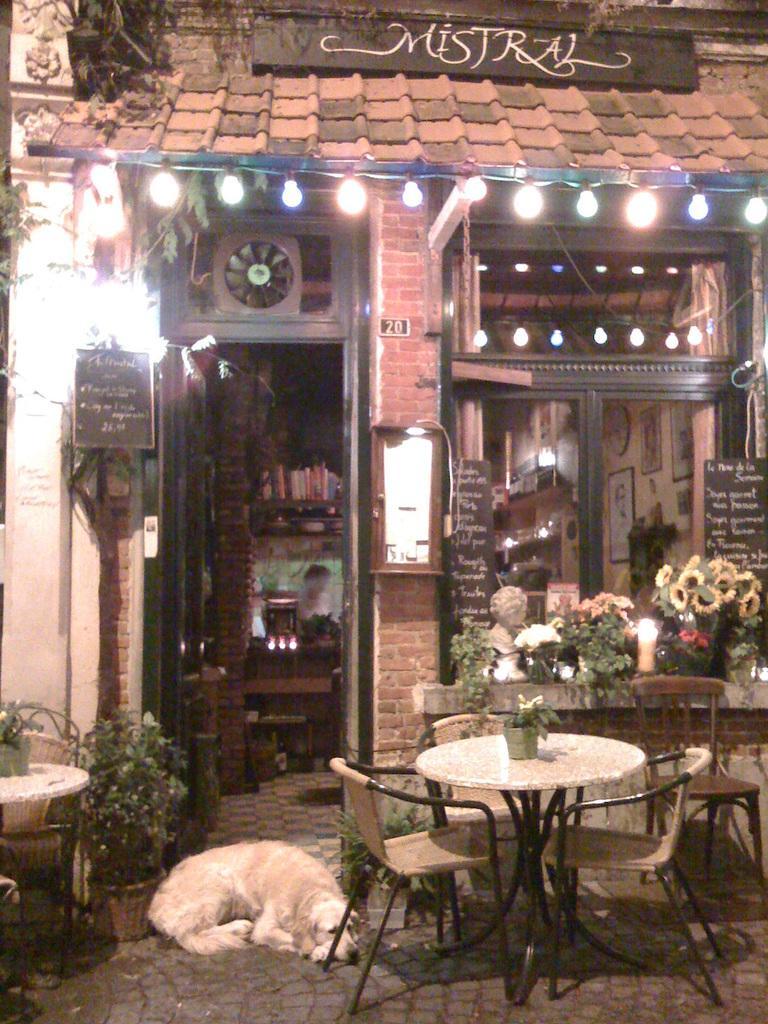Can you describe this image briefly? There is a store which has tables,chairs and floors in front of it and there is a dog sleeping in front of the door. 